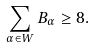Convert formula to latex. <formula><loc_0><loc_0><loc_500><loc_500>\sum _ { \alpha \in W } B _ { \alpha } \geq 8 .</formula> 